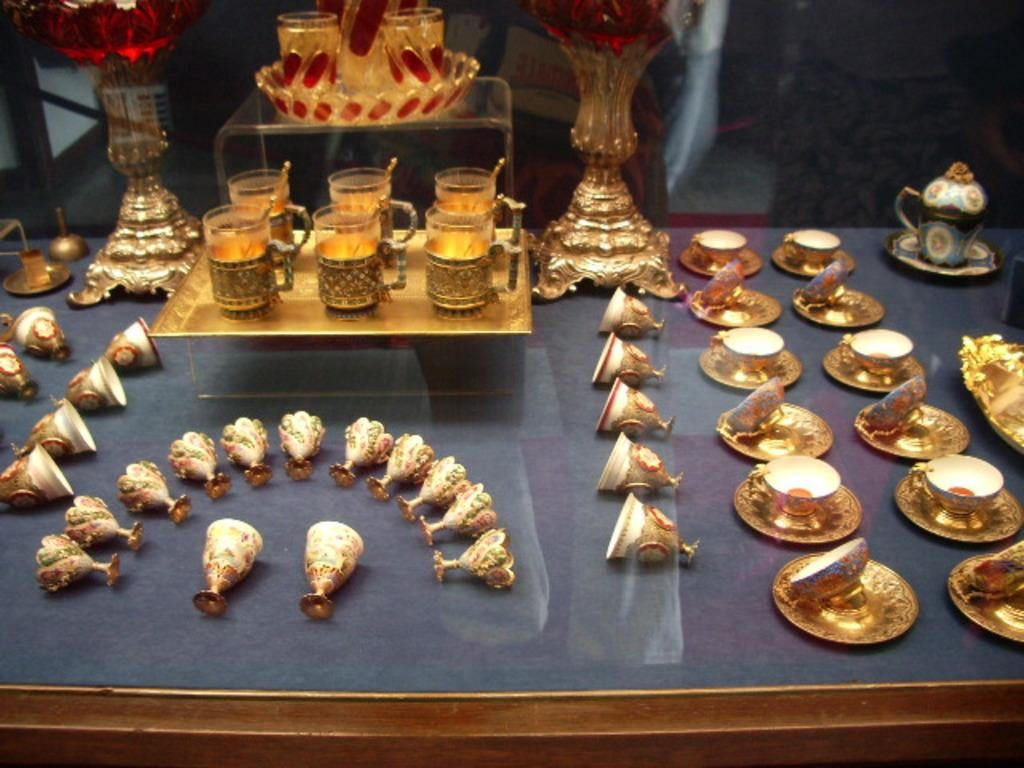What type of tableware is present in the image? There are glasses and plates in the image. What is the color of the glasses and plates? The glasses and plates are golden in color. What other color is present in the image besides gold? There are red-colored objects in the image. How would you describe the lighting in the image? The background of the image is dark. Reasoning: Let' Let's think step by step in order to produce the conversation. We start by identifying the main subjects in the image, which are the glasses and plates. Then, we describe their color and mention the presence of red-colored objects. Finally, we address the background lighting, which is dark. Each question is designed to elicit a specific detail about the image that is known from the provided facts. Absurd Question/Answer: How does the loss of the boot affect the learning process in the image? There is no mention of a boot or a learning process in the image, so it's not possible to determine how the loss of the boot might affect the learning process. How does the loss of the boot affect the learning process in the image? There is no mention of a boot or a learning process in the image, so it's not possible to determine how the loss of the boot might affect the learning process. 